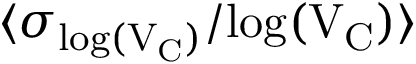<formula> <loc_0><loc_0><loc_500><loc_500>\langle \sigma _ { { \log } ( V _ { C } ) } / { \log } ( V _ { C } ) \rangle</formula> 